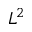Convert formula to latex. <formula><loc_0><loc_0><loc_500><loc_500>L ^ { 2 }</formula> 